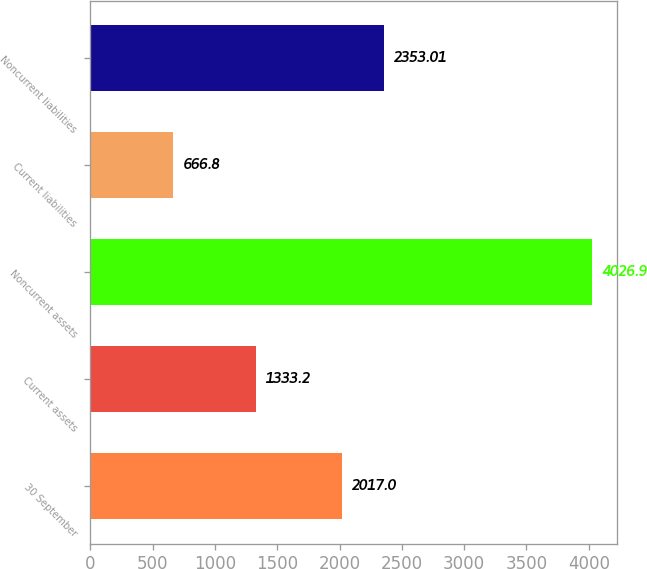<chart> <loc_0><loc_0><loc_500><loc_500><bar_chart><fcel>30 September<fcel>Current assets<fcel>Noncurrent assets<fcel>Current liabilities<fcel>Noncurrent liabilities<nl><fcel>2017<fcel>1333.2<fcel>4026.9<fcel>666.8<fcel>2353.01<nl></chart> 